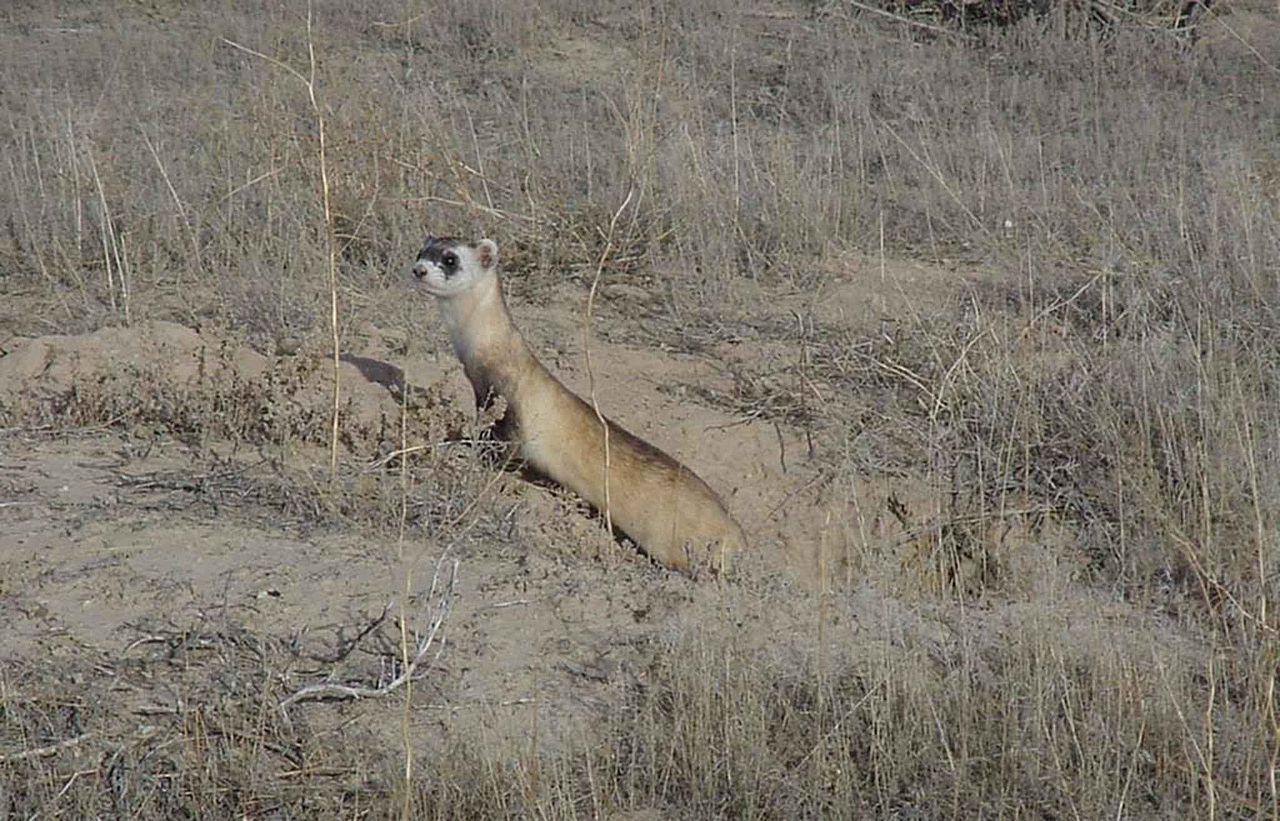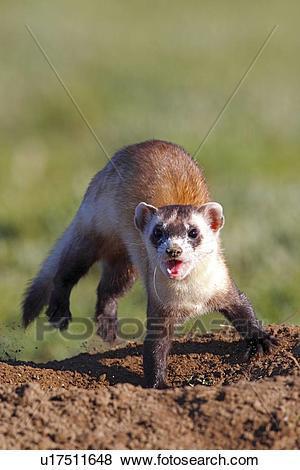The first image is the image on the left, the second image is the image on the right. For the images shown, is this caption "Each image shows exactly one ferret emerging from a hole in the ground." true? Answer yes or no. No. 